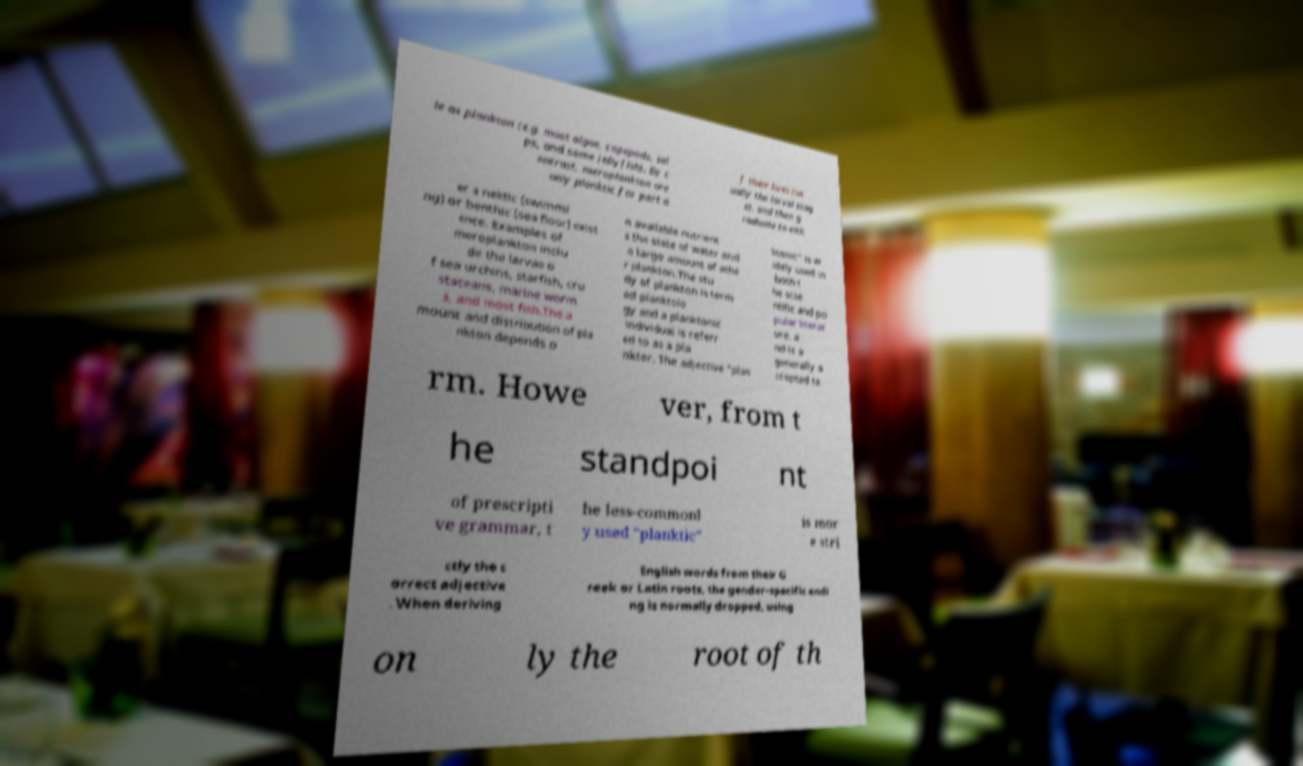Can you read and provide the text displayed in the image?This photo seems to have some interesting text. Can you extract and type it out for me? le as plankton (e.g. most algae, copepods, sal ps, and some jellyfish). By c ontrast, meroplankton are only planktic for part o f their lives (us ually the larval stag e), and then g raduate to eith er a nektic (swimmi ng) or benthic (sea floor) exist ence. Examples of meroplankton inclu de the larvae o f sea urchins, starfish, cru staceans, marine worm s, and most fish.The a mount and distribution of pla nkton depends o n available nutrient s the state of water and a large amount of othe r plankton.The stu dy of plankton is term ed planktolo gy and a planktonic individual is referr ed to as a pla nkter. The adjective "plan ktonic" is w idely used in both t he scie ntific and po pular literat ure, a nd is a generally a ccepted te rm. Howe ver, from t he standpoi nt of prescripti ve grammar, t he less-commonl y used "planktic" is mor e stri ctly the c orrect adjective . When deriving English words from their G reek or Latin roots, the gender-specific endi ng is normally dropped, using on ly the root of th 